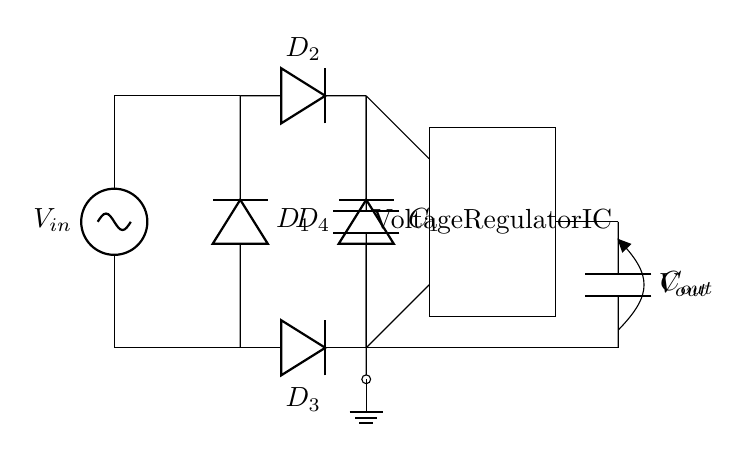What is the input voltage of the circuit? The input voltage is indicated by the notation V_in, which is connected to the top of the circuit near the wind turbine symbol.
Answer: V_in How many diodes are used in the rectifier? The diagram shows four diodes labeled D_1, D_2, D_3, and D_4, all of which are part of the rectifier section.
Answer: Four What component smooths the output voltage? The component that smooths the output voltage is the capacitor labeled C_1, located between the two outputs of the diodes in the rectifier section.
Answer: C_1 Explain how the voltage regulator operates in this circuit. The voltage regulator, represented as an integrated circuit, receives the smoothed voltage from the capacitor C_1, stabilizing the output voltage V_out. It does this by adjusting the output based on the load demand and maintaining a constant output voltage level regardless of variations in input voltage or load conditions.
Answer: Stabilizes output voltage What is the role of the output capacitor in this circuit? The output capacitor labeled C_out is connected to the output V_out, assisting in further smoothing and filtering the output voltage to ensure a stable power supply to the connected load. It reduces voltage ripple by providing energy during sudden load changes.
Answer: Smoothing output voltage What type of configuration is the rectifier used in this circuit? The rectifier is configured in a bridge rectifier arrangement, where the four diodes are arranged in such a way to convert AC input from the wind turbine into a DC output, allowing efficient power conversion regardless of the input polarity.
Answer: Bridge rectifier What is the output voltage denoted as in this circuit? The output voltage is denoted as V_out, indicated at the output of the voltage regulator, and represents the stabilized DC voltage delivered to the load.
Answer: V_out 